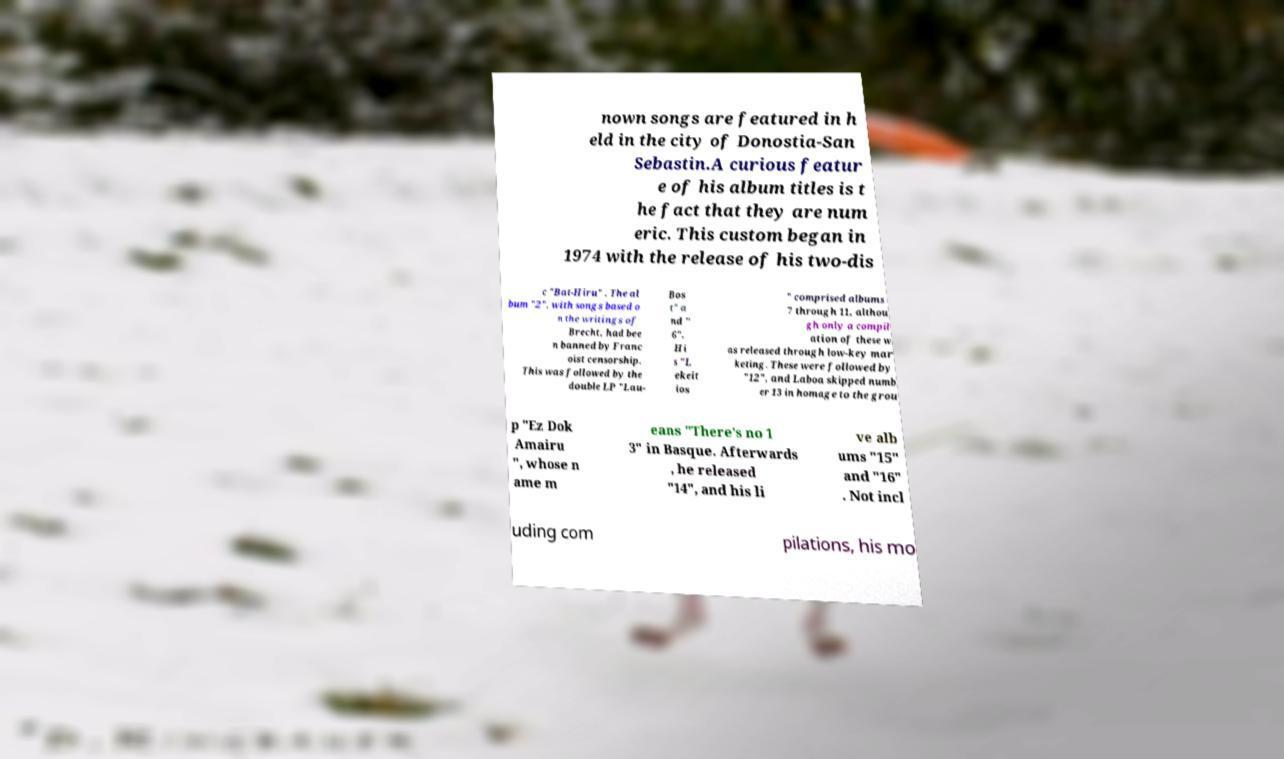Can you accurately transcribe the text from the provided image for me? nown songs are featured in h eld in the city of Donostia-San Sebastin.A curious featur e of his album titles is t he fact that they are num eric. This custom began in 1974 with the release of his two-dis c "Bat-Hiru" . The al bum "2", with songs based o n the writings of Brecht, had bee n banned by Franc oist censorship. This was followed by the double LP "Lau- Bos t" a nd " 6". Hi s "L ekeit ios " comprised albums 7 through 11, althou gh only a compil ation of these w as released through low-key mar keting. These were followed by "12", and Laboa skipped numb er 13 in homage to the grou p "Ez Dok Amairu ", whose n ame m eans "There's no 1 3" in Basque. Afterwards , he released "14", and his li ve alb ums "15" and "16" . Not incl uding com pilations, his mo 